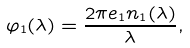<formula> <loc_0><loc_0><loc_500><loc_500>\varphi _ { 1 } ( \lambda ) = \frac { 2 \pi e _ { 1 } n _ { 1 } ( \lambda ) } { \lambda } ,</formula> 